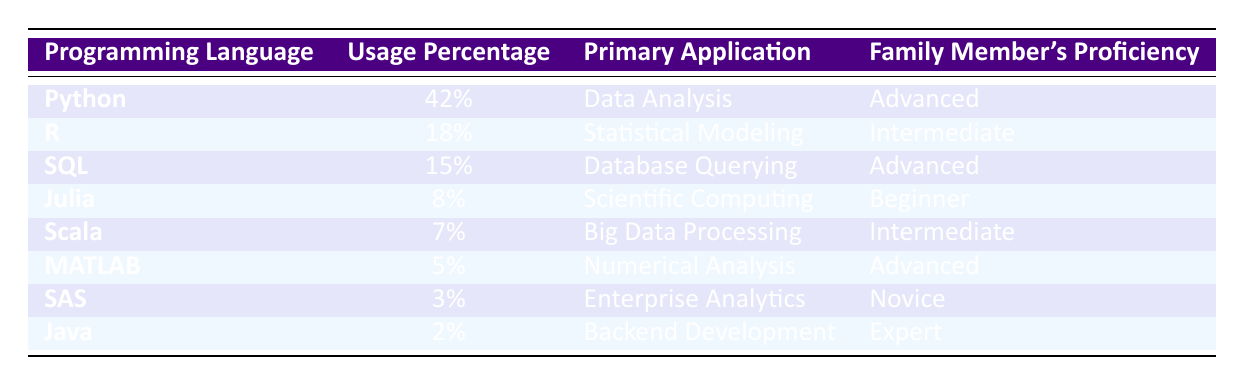What programming language has the highest usage percentage? By scanning the "Usage Percentage" column, we can see that Python has the highest value at 42%.
Answer: Python What is the primary application of SQL? Referring to the "Primary Application" column, SQL is used for "Database Querying."
Answer: Database Querying Is the family member's proficiency for MATLAB advanced? Looking at the "Family Member's Proficiency" column, it indicates that the proficiency level for MATLAB is "Advanced." Therefore, this statement is true.
Answer: Yes What percentage of data science projects use Julia or Scala? First, we identify the usage percentages: Julia is at 8% and Scala is at 7%. Next, we add these percentages together: 8% + 7% = 15%.
Answer: 15% Which programming language has the least usage percentage? By examining the "Usage Percentage" column, Java is at 2%, which is lower than all other programming languages listed.
Answer: Java How many programming languages have a usage percentage of 15% or more? Reviewing the "Usage Percentage" column, we see Python (42%), R (18%), and SQL (15%) fall within this criteria. Therefore, there are three languages that fit this requirement.
Answer: 3 Is there any programming language used for enterprise analytics? Looking at the "Primary Application" column, SAS is designated for "Enterprise Analytics," confirming that there is indeed a language dedicated to this area.
Answer: Yes What is the average usage percentage of the programming languages listed? We sum the usage percentages: 42% + 18% + 15% + 8% + 7% + 5% + 3% + 2% = 100%. There are 8 languages, so the average usage percentage is 100% / 8 = 12.5%.
Answer: 12.5% 